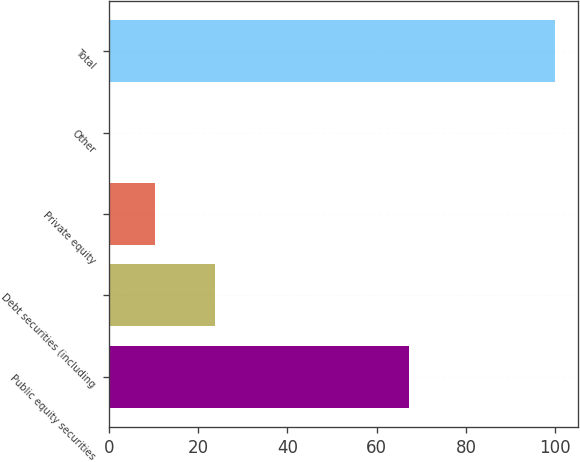<chart> <loc_0><loc_0><loc_500><loc_500><bar_chart><fcel>Public equity securities<fcel>Debt securities (including<fcel>Private equity<fcel>Other<fcel>Total<nl><fcel>67.3<fcel>23.7<fcel>10.27<fcel>0.3<fcel>100<nl></chart> 